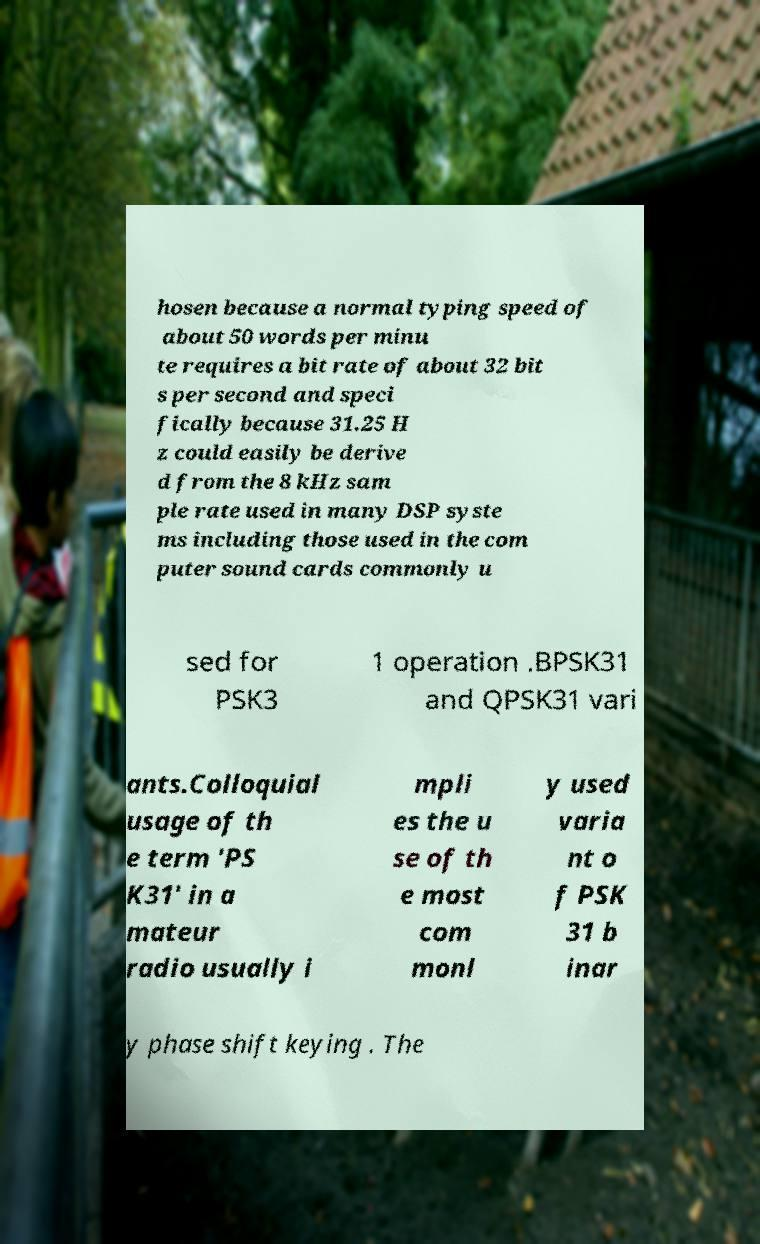Can you read and provide the text displayed in the image?This photo seems to have some interesting text. Can you extract and type it out for me? hosen because a normal typing speed of about 50 words per minu te requires a bit rate of about 32 bit s per second and speci fically because 31.25 H z could easily be derive d from the 8 kHz sam ple rate used in many DSP syste ms including those used in the com puter sound cards commonly u sed for PSK3 1 operation .BPSK31 and QPSK31 vari ants.Colloquial usage of th e term 'PS K31' in a mateur radio usually i mpli es the u se of th e most com monl y used varia nt o f PSK 31 b inar y phase shift keying . The 